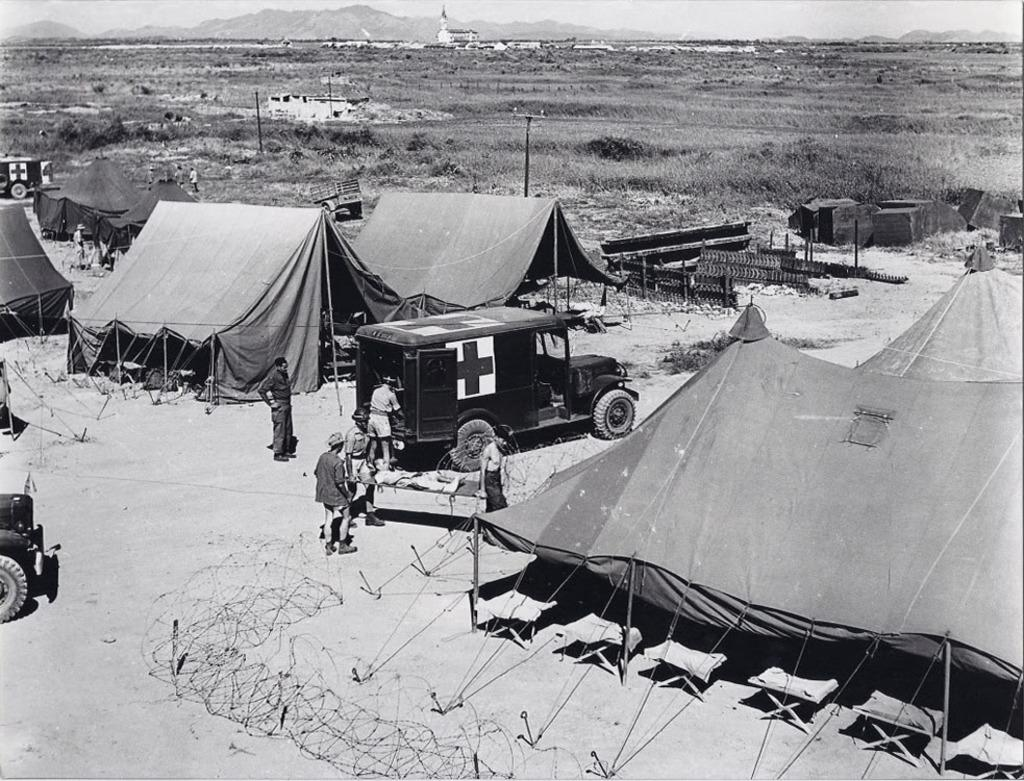What type of structures can be seen in the image? There are tents in the image. What are the tents supported by? There are poles in the image that support the tents. What type of vehicles are present in the image? There are vehicles in the image. What can be found on the ground in the image? There are objects on the ground in the image. What is visible in the background of the image? There are mountains, a building, and grass in the background of the image. Are there any people visible in the image? Yes, there are people in the background of the image. What is the color scheme of the image? The image is in black and white color. What type of mouth can be seen on the eggnog in the image? There is no eggnog or mouth present in the image. What invention is being demonstrated in the image? There is no invention being demonstrated in the image. 